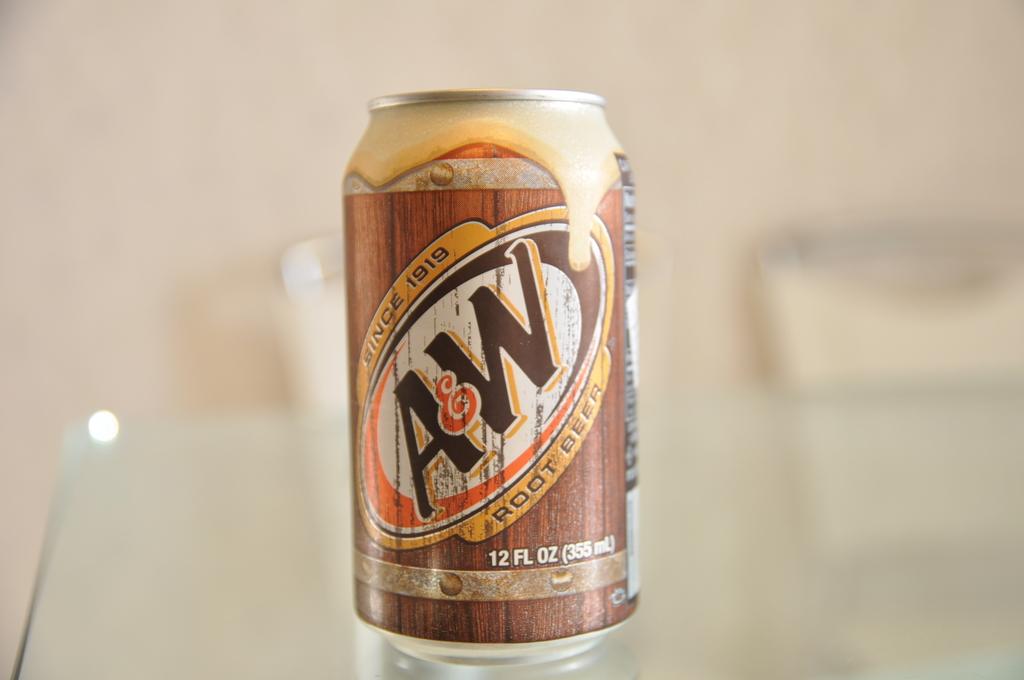What brand is this soda?
Offer a very short reply. A&w. 